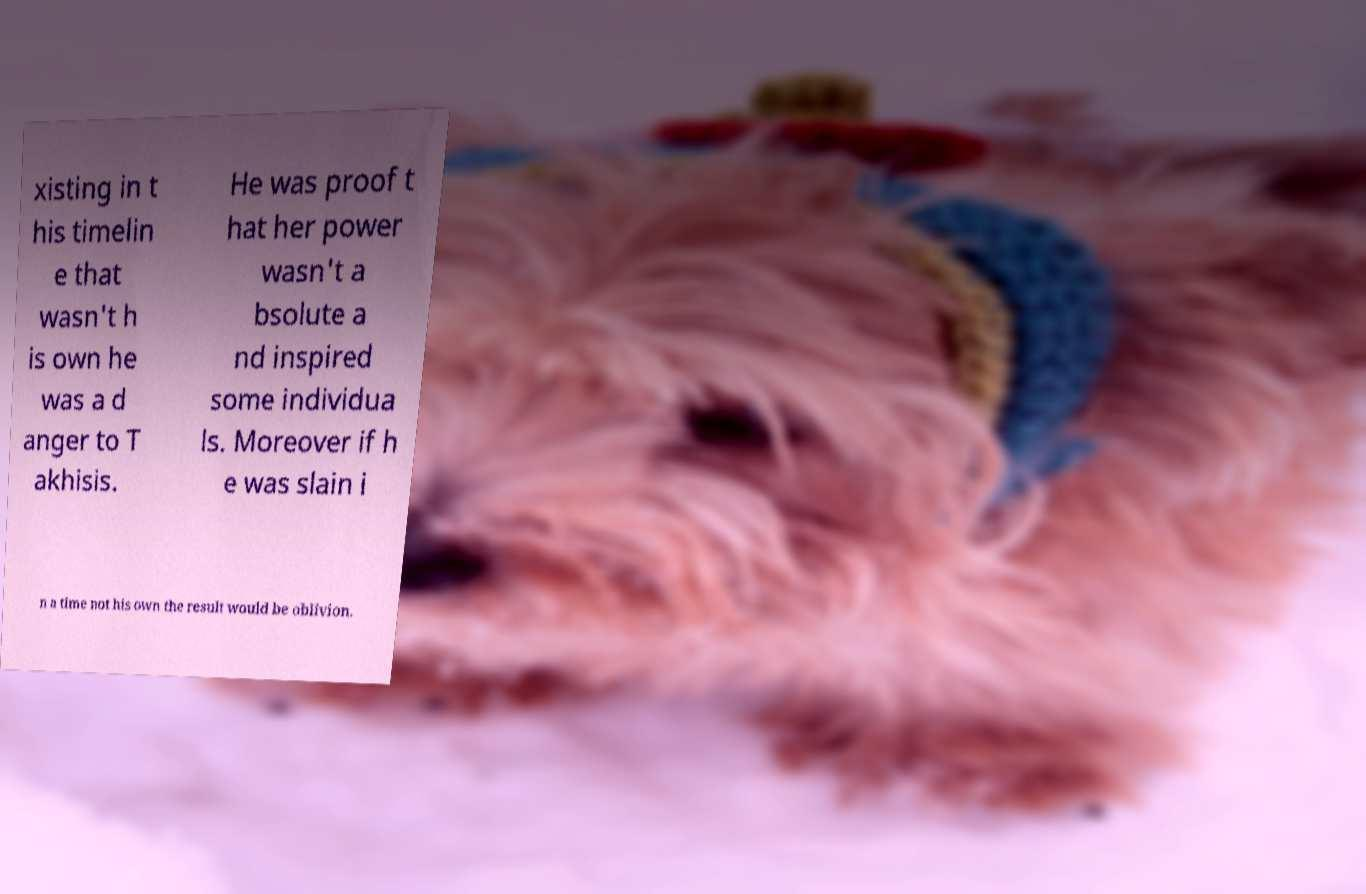Please identify and transcribe the text found in this image. xisting in t his timelin e that wasn't h is own he was a d anger to T akhisis. He was proof t hat her power wasn't a bsolute a nd inspired some individua ls. Moreover if h e was slain i n a time not his own the result would be oblivion. 